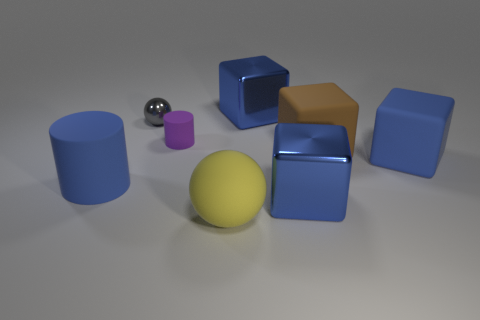How many blue blocks must be subtracted to get 1 blue blocks? 2 Subtract all large brown blocks. How many blocks are left? 3 Subtract all gray balls. How many blue cubes are left? 3 Subtract all brown cubes. How many cubes are left? 3 Subtract 1 cubes. How many cubes are left? 3 Add 2 red rubber spheres. How many objects exist? 10 Subtract all spheres. How many objects are left? 6 Subtract all green cubes. Subtract all purple balls. How many cubes are left? 4 Subtract all blue cylinders. Subtract all big blue rubber cylinders. How many objects are left? 6 Add 7 big matte blocks. How many big matte blocks are left? 9 